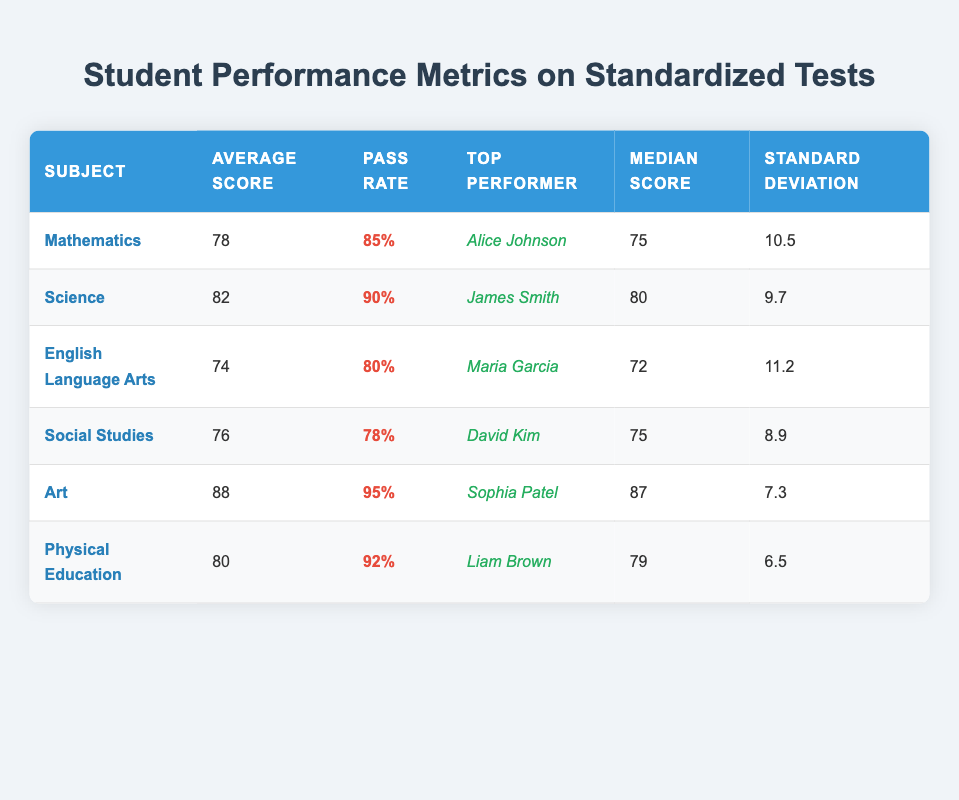What is the average score in Science? The average score for Science is listed in the table as 82.
Answer: 82 Which subject has the highest average score? By comparing the average scores from each subject, Art has the highest average score at 88.
Answer: Art Who is the top performer in English Language Arts? The table shows that the top performer in English Language Arts is Maria Garcia.
Answer: Maria Garcia What is the pass rate for Mathematics? The pass rate for Mathematics is provided in the table as 85%.
Answer: 85% Is the median score for Physical Education higher than that of Social Studies? The median score for Physical Education is 79, while for Social Studies it is 75. Since 79 is greater than 75, the statement is true.
Answer: Yes What is the difference between the average scores of Science and Mathematics? The average score for Science is 82, and for Mathematics, it is 78. Therefore, the difference is 82 - 78 = 4.
Answer: 4 Which subject has the lowest pass rate, and what is that rate? By reviewing the pass rates, Social Studies has the lowest pass rate at 78%.
Answer: Social Studies, 78% Calculate the average of the median scores for all subjects. The median scores to calculate are 75 (Math) + 80 (Science) + 72 (English) + 75 (Social Studies) + 87 (Art) + 79 (PE) = 468. There are 6 subjects, so the average median score is 468/6 = 78.
Answer: 78 Are the standard deviations for Science and English Language Arts equal? The standard deviation for Science is 9.7, and for English Language Arts, it is 11.2. Since these values are not equal, the answer is no.
Answer: No Which subject's average score is closest to 80? The average scores for Physical Education (80) and Mathematics (78) are both close to 80, but Physical Education is exactly 80.
Answer: Physical Education What is the total average score for all subjects combined? The total average score is calculated by summing up each average score (78 + 82 + 74 + 76 + 88 + 80) = 478, then dividing by the number of subjects 478/6 = 79.67.
Answer: 79.67 